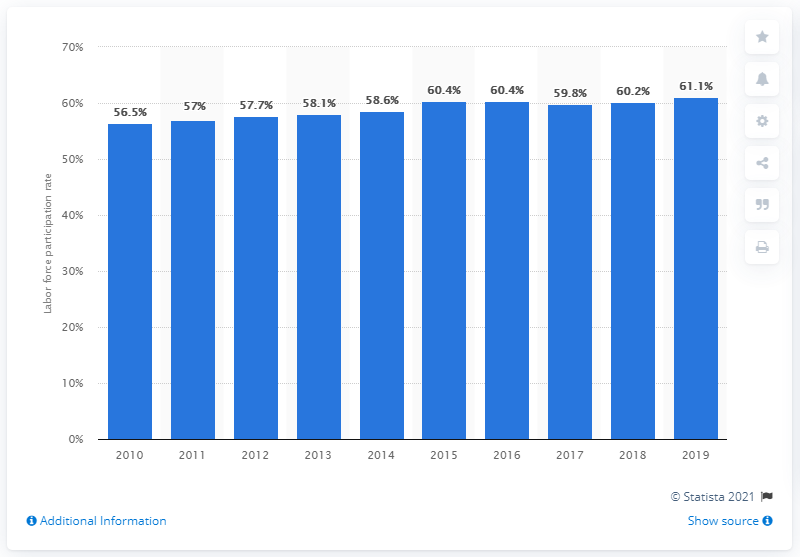Point out several critical features in this image. The female labor force participation rate in Singapore in 2019 was 61.1%. 